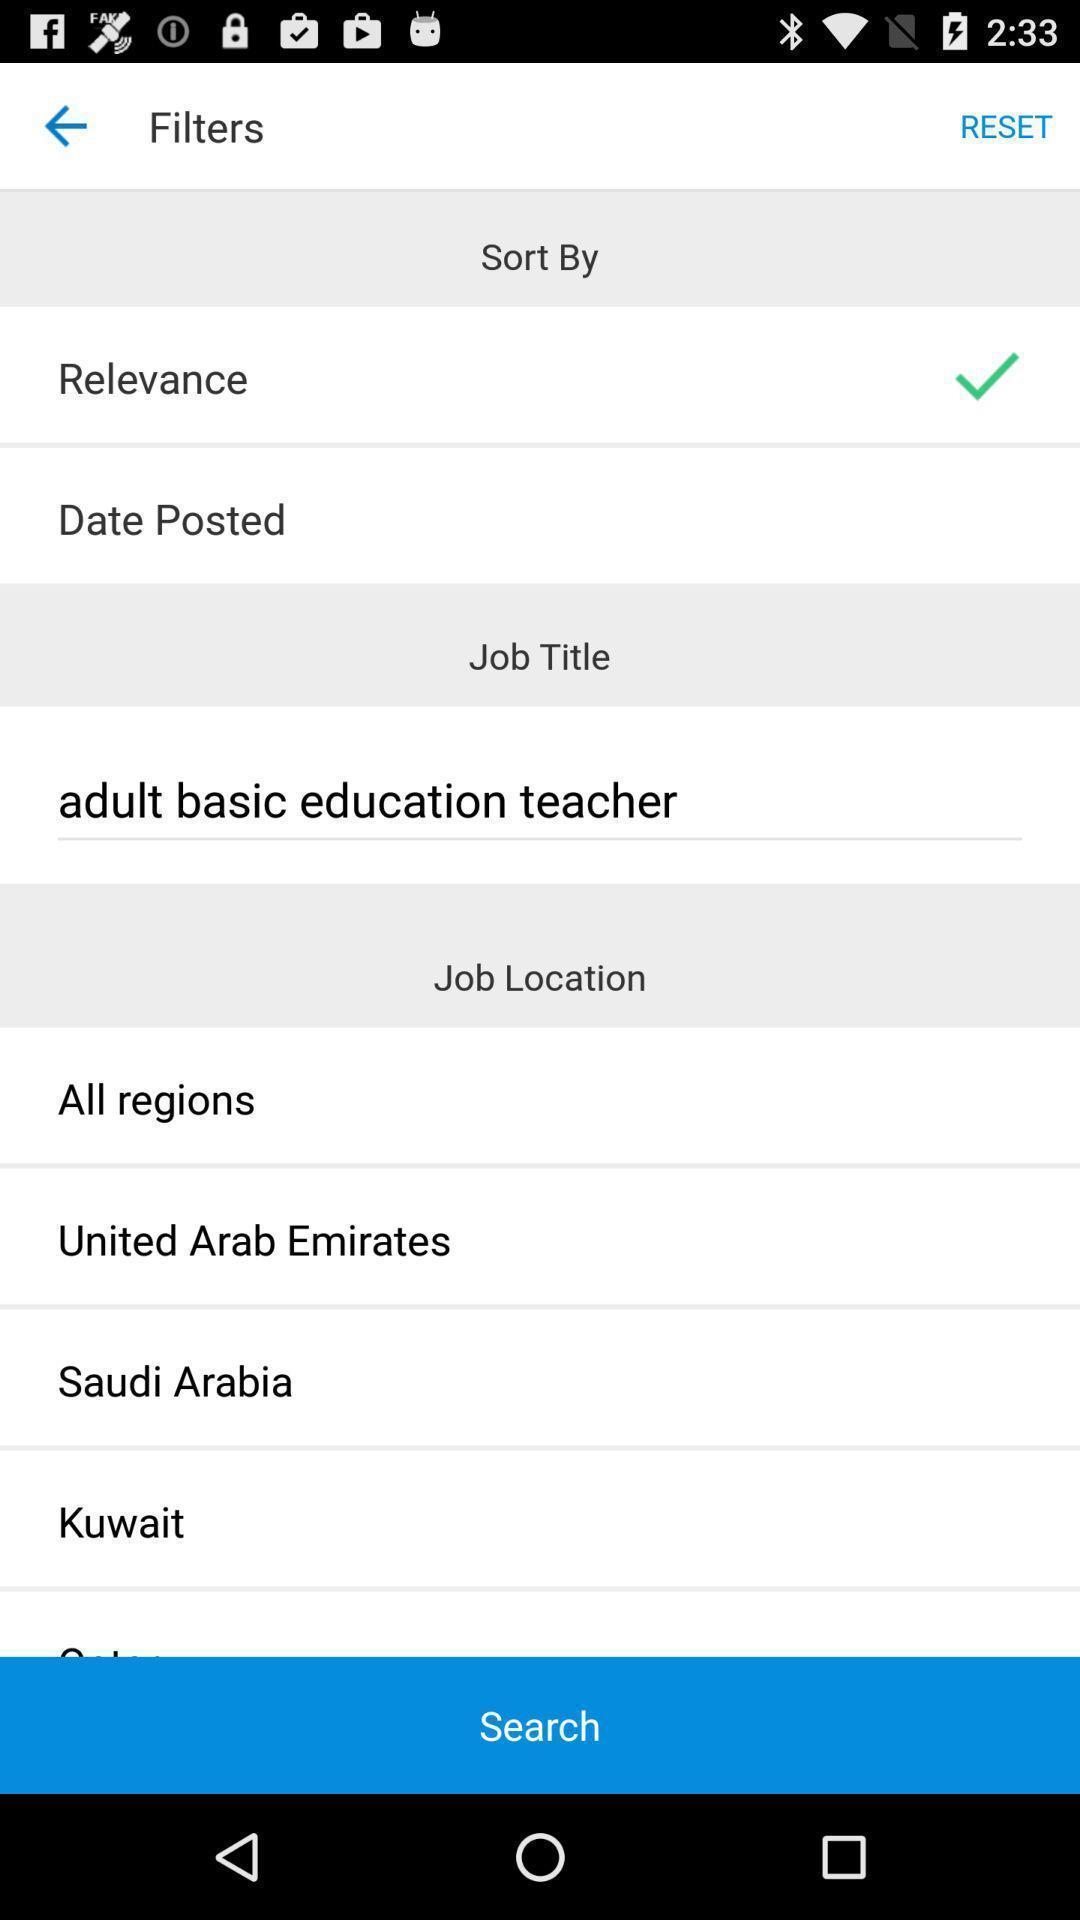Explain what's happening in this screen capture. Screen shows multiple options in filters of a job application. 